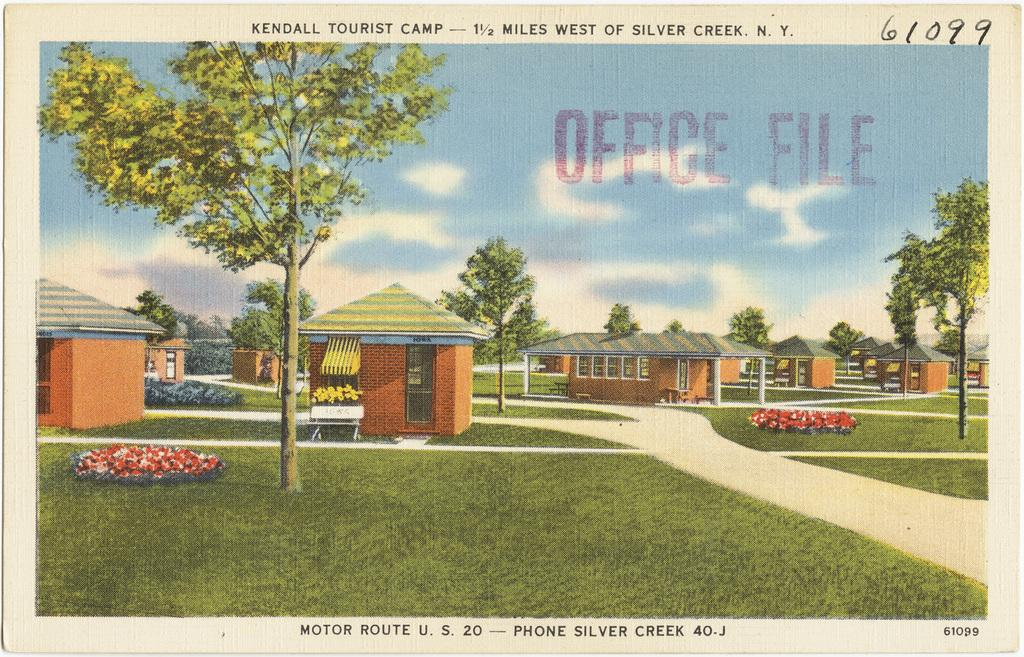What is the main subject of the poster in the image? The poster contains images of houses, trees, grass, and clouds. What other elements are present on the poster besides the images? The poster contains text. Can you see the toad jumping on the wrist in the image? There is no toad or wrist present in the image; the image only contains a poster with images and text. 